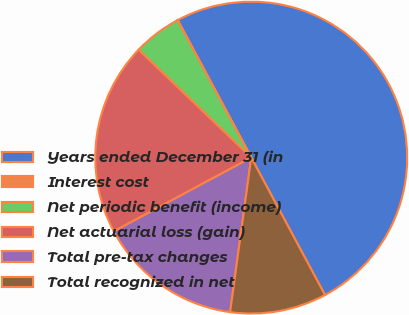<chart> <loc_0><loc_0><loc_500><loc_500><pie_chart><fcel>Years ended December 31 (in<fcel>Interest cost<fcel>Net periodic benefit (income)<fcel>Net actuarial loss (gain)<fcel>Total pre-tax changes<fcel>Total recognized in net<nl><fcel>49.98%<fcel>0.01%<fcel>5.01%<fcel>20.0%<fcel>15.0%<fcel>10.0%<nl></chart> 